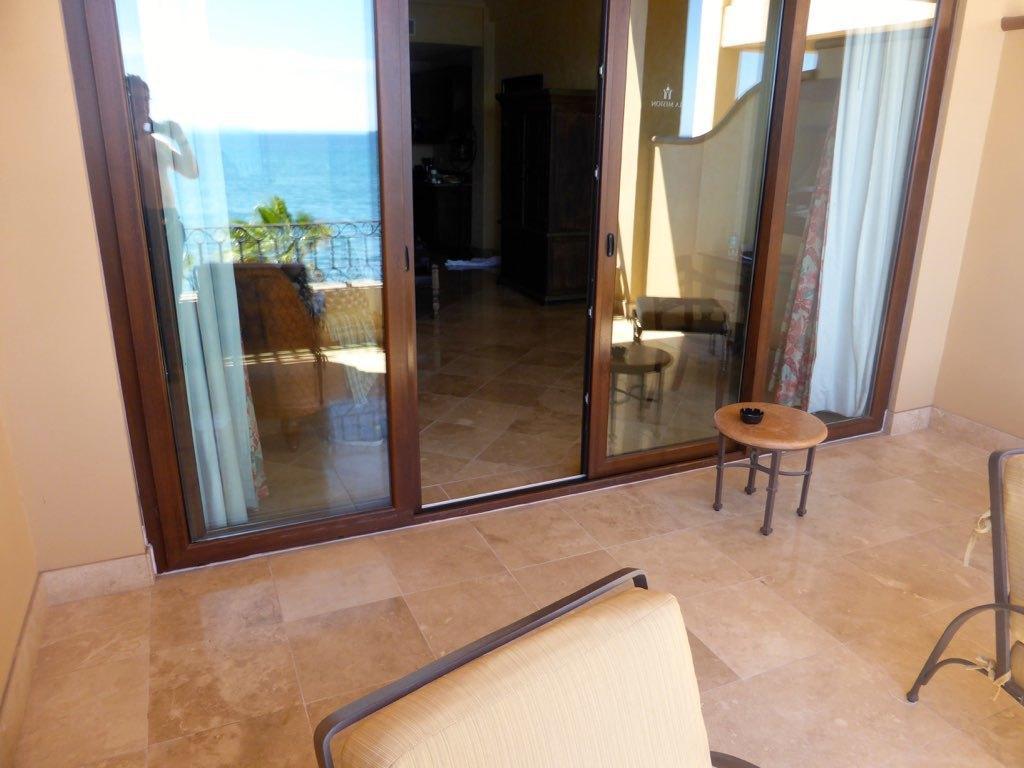Can you describe this image briefly? In this image I can see there is a glass door. On this image a woman is standing and taking the photograph of it. On the right side there are chairs in this image. 